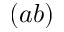Convert formula to latex. <formula><loc_0><loc_0><loc_500><loc_500>( a b )</formula> 